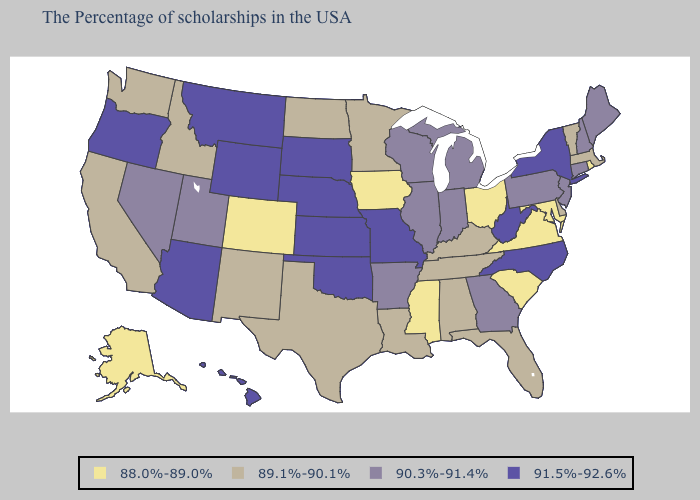What is the lowest value in the MidWest?
Be succinct. 88.0%-89.0%. Does Utah have the lowest value in the West?
Be succinct. No. Name the states that have a value in the range 90.3%-91.4%?
Give a very brief answer. Maine, New Hampshire, Connecticut, New Jersey, Pennsylvania, Georgia, Michigan, Indiana, Wisconsin, Illinois, Arkansas, Utah, Nevada. Which states hav the highest value in the South?
Short answer required. North Carolina, West Virginia, Oklahoma. Name the states that have a value in the range 90.3%-91.4%?
Quick response, please. Maine, New Hampshire, Connecticut, New Jersey, Pennsylvania, Georgia, Michigan, Indiana, Wisconsin, Illinois, Arkansas, Utah, Nevada. What is the lowest value in states that border New Jersey?
Write a very short answer. 89.1%-90.1%. Among the states that border Michigan , does Ohio have the highest value?
Quick response, please. No. Name the states that have a value in the range 91.5%-92.6%?
Concise answer only. New York, North Carolina, West Virginia, Missouri, Kansas, Nebraska, Oklahoma, South Dakota, Wyoming, Montana, Arizona, Oregon, Hawaii. Name the states that have a value in the range 90.3%-91.4%?
Quick response, please. Maine, New Hampshire, Connecticut, New Jersey, Pennsylvania, Georgia, Michigan, Indiana, Wisconsin, Illinois, Arkansas, Utah, Nevada. What is the value of Massachusetts?
Quick response, please. 89.1%-90.1%. What is the value of Montana?
Give a very brief answer. 91.5%-92.6%. What is the value of Michigan?
Be succinct. 90.3%-91.4%. Name the states that have a value in the range 90.3%-91.4%?
Write a very short answer. Maine, New Hampshire, Connecticut, New Jersey, Pennsylvania, Georgia, Michigan, Indiana, Wisconsin, Illinois, Arkansas, Utah, Nevada. What is the highest value in the West ?
Keep it brief. 91.5%-92.6%. Does Ohio have the lowest value in the USA?
Write a very short answer. Yes. 